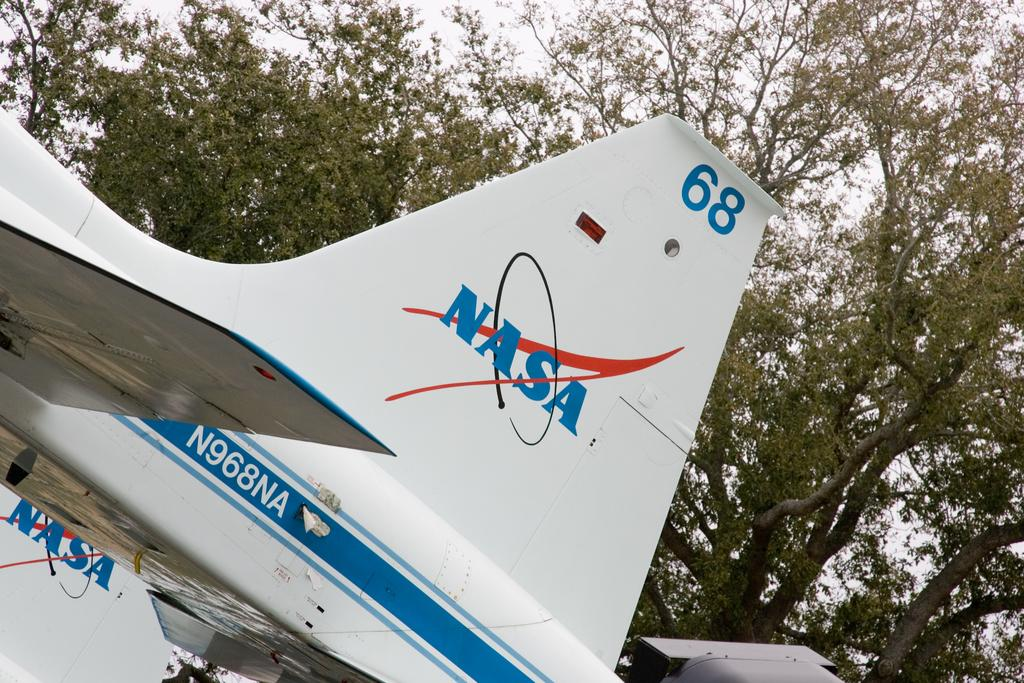<image>
Give a short and clear explanation of the subsequent image. The tail fin of a NASA space shuttle. 